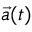Convert formula to latex. <formula><loc_0><loc_0><loc_500><loc_500>\vec { a } ( t )</formula> 